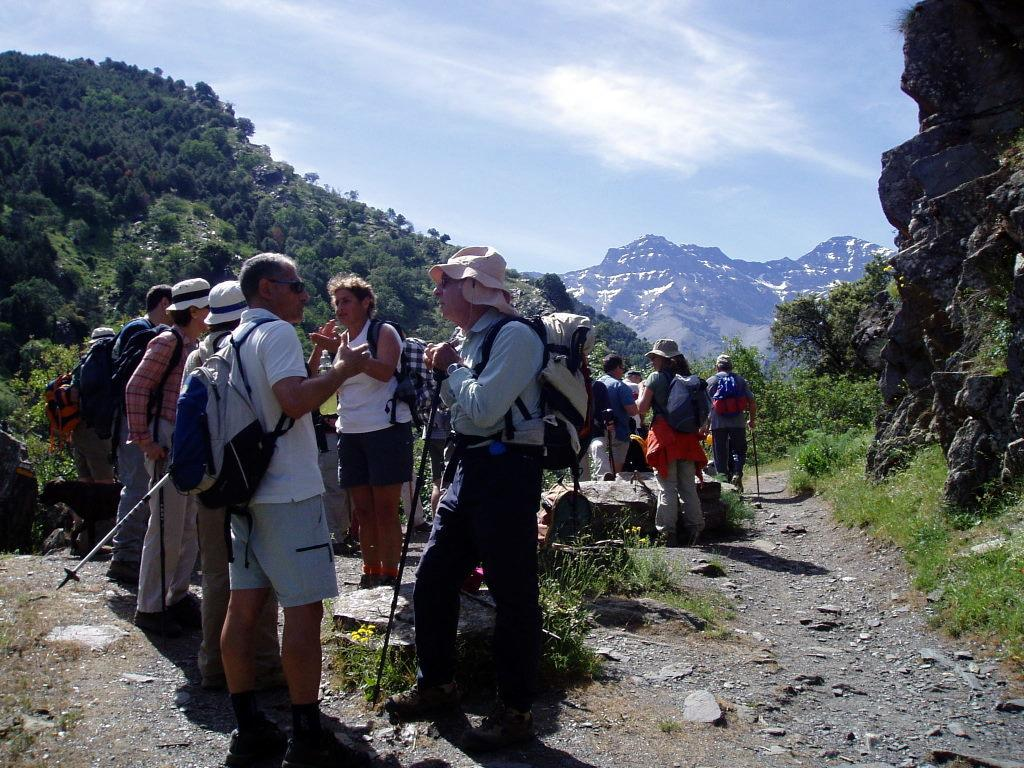How many people are in the image? There is a group of people in the image, but the exact number cannot be determined from the provided facts. What can be seen in the background of the image? Trees and mountains are visible in the background of the image. What is visible at the top of the image? The sky is visible at the top of the image. Where is the basin located in the image? There is no basin present in the image. What type of building can be seen in the image? There is no building present in the image; it features a group of people, trees, mountains, and the sky. 